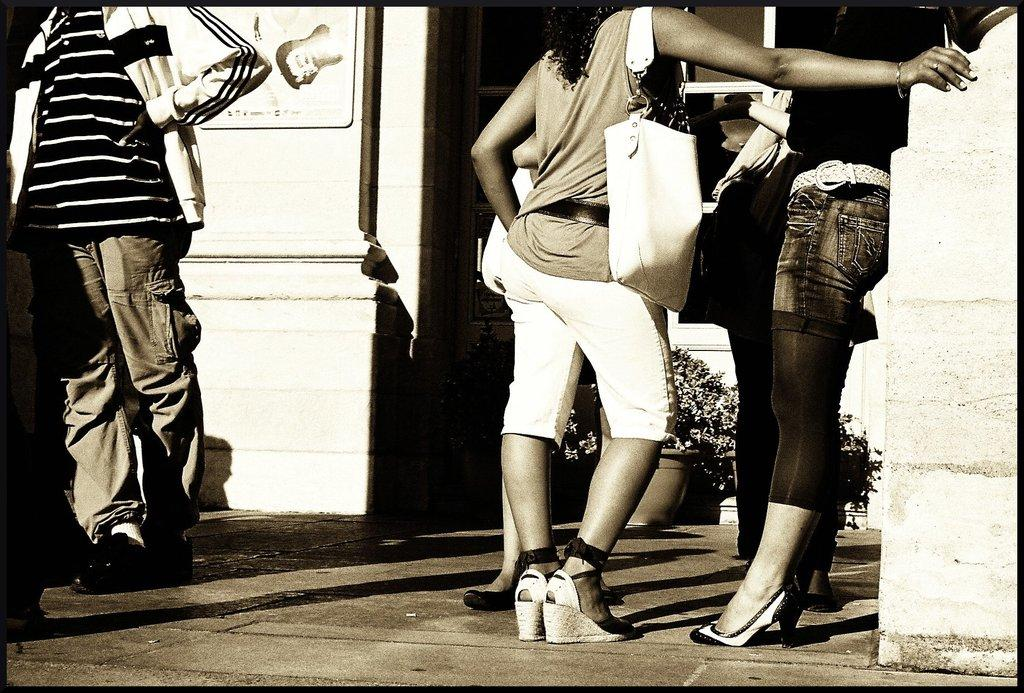What can be seen in the image? There are people standing in the image. What else is present in the image besides the people? There are flower pots in the image. Can you describe the background of the image? There is a white-colored wall on the right side of the image. Who won the competition in the image? There is no competition present in the image. Can you describe the feather on the grandmother's hat in the image? There is no grandmother or feather present in the image. 